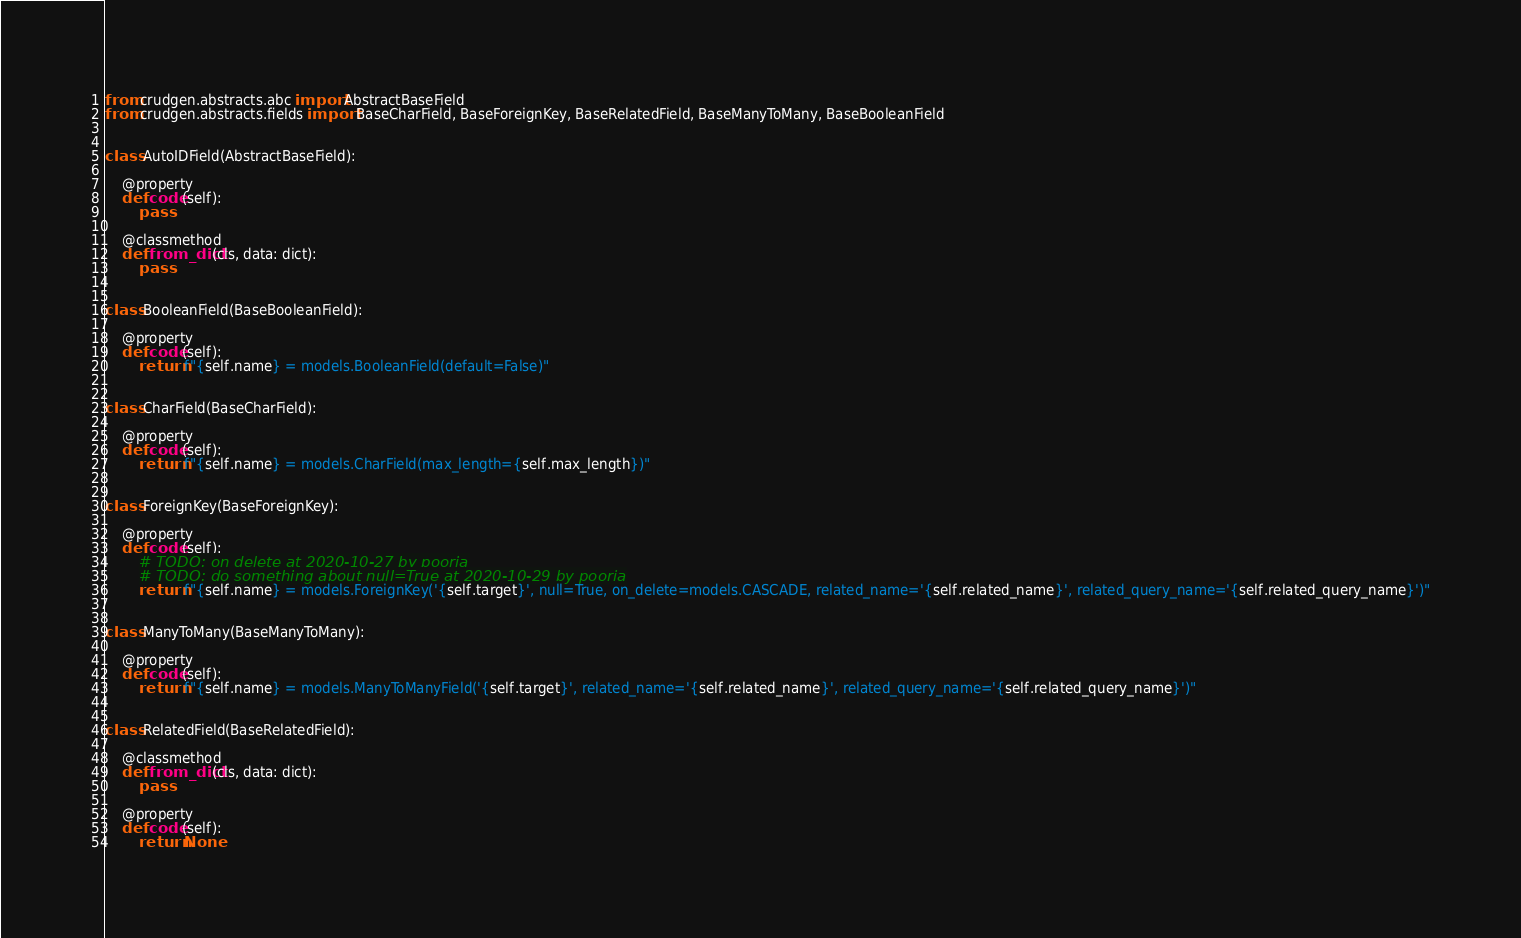<code> <loc_0><loc_0><loc_500><loc_500><_Python_>from crudgen.abstracts.abc import AbstractBaseField
from crudgen.abstracts.fields import BaseCharField, BaseForeignKey, BaseRelatedField, BaseManyToMany, BaseBooleanField


class AutoIDField(AbstractBaseField):

    @property
    def code(self):
        pass

    @classmethod
    def from_dict(cls, data: dict):
        pass


class BooleanField(BaseBooleanField):

    @property
    def code(self):
        return f"{self.name} = models.BooleanField(default=False)"


class CharField(BaseCharField):

    @property
    def code(self):
        return f"{self.name} = models.CharField(max_length={self.max_length})"


class ForeignKey(BaseForeignKey):

    @property
    def code(self):
        # TODO: on delete at 2020-10-27 by pooria
        # TODO: do something about null=True at 2020-10-29 by pooria
        return f"{self.name} = models.ForeignKey('{self.target}', null=True, on_delete=models.CASCADE, related_name='{self.related_name}', related_query_name='{self.related_query_name}')"


class ManyToMany(BaseManyToMany):

    @property
    def code(self):
        return f"{self.name} = models.ManyToManyField('{self.target}', related_name='{self.related_name}', related_query_name='{self.related_query_name}')"


class RelatedField(BaseRelatedField):

    @classmethod
    def from_dict(cls, data: dict):
        pass

    @property
    def code(self):
        return None

</code> 